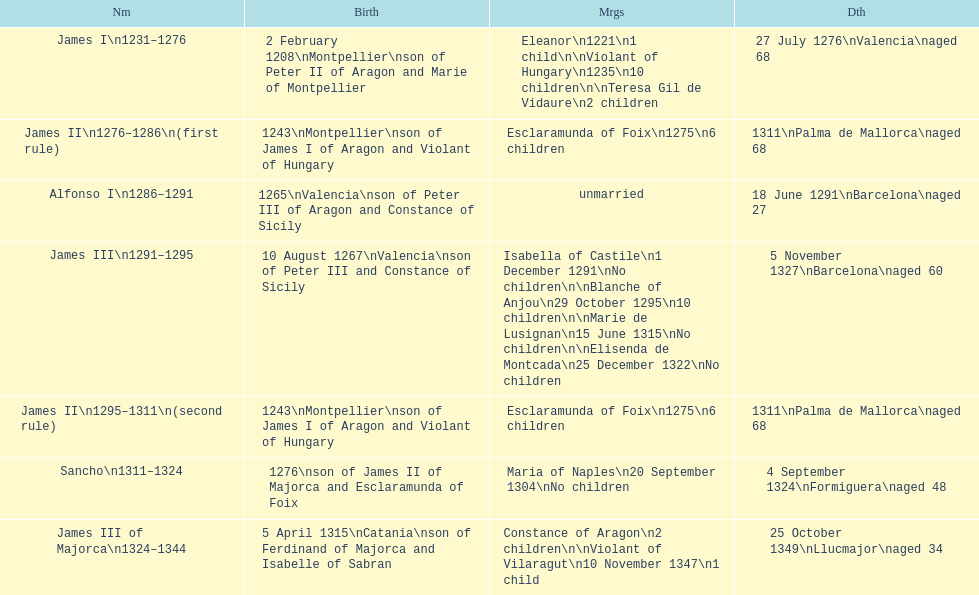Which two monarchs had no children? Alfonso I, Sancho. 